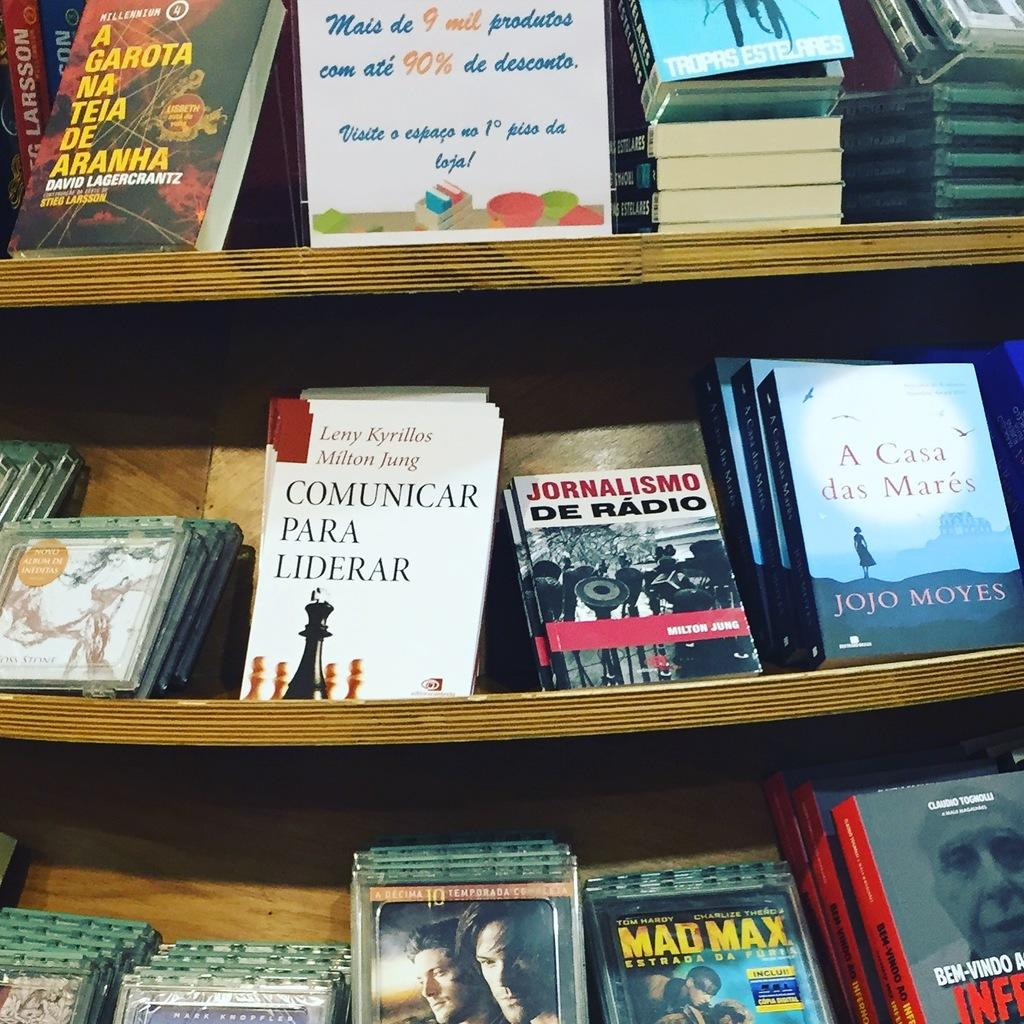<image>
Render a clear and concise summary of the photo. The book Comunicar Para Liderar is the center book of other books on the bookshelves. 